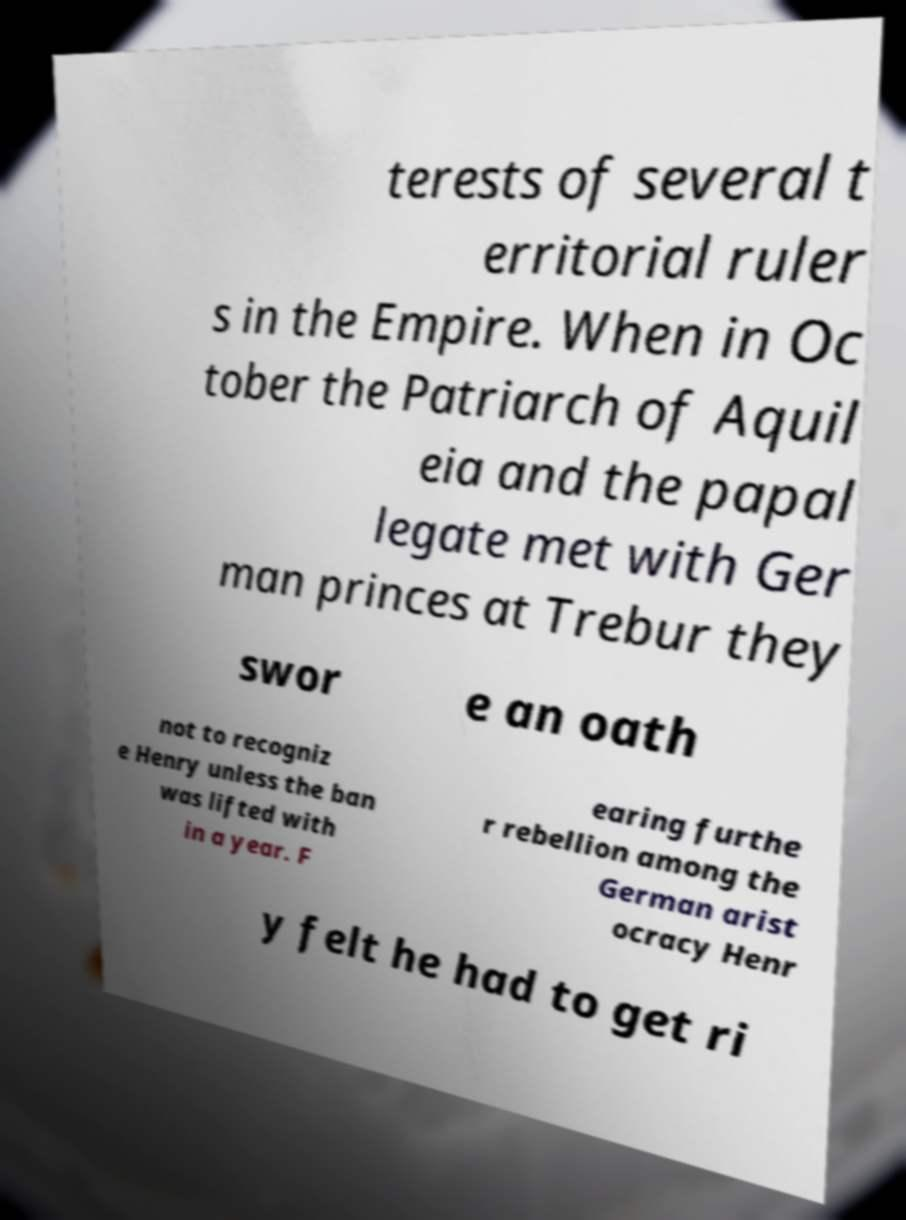There's text embedded in this image that I need extracted. Can you transcribe it verbatim? terests of several t erritorial ruler s in the Empire. When in Oc tober the Patriarch of Aquil eia and the papal legate met with Ger man princes at Trebur they swor e an oath not to recogniz e Henry unless the ban was lifted with in a year. F earing furthe r rebellion among the German arist ocracy Henr y felt he had to get ri 